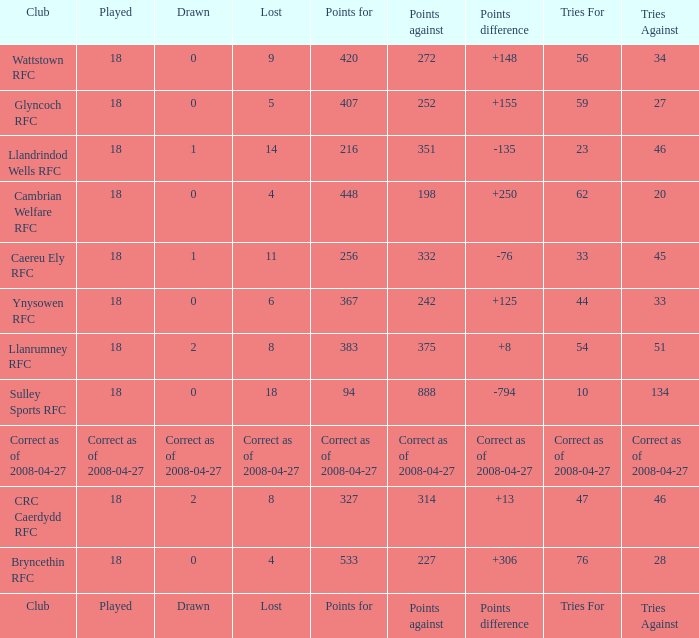What is the value for the item "Tries" when the value of the item "Played" is 18 and the value of the item "Points" is 375? 54.0. 